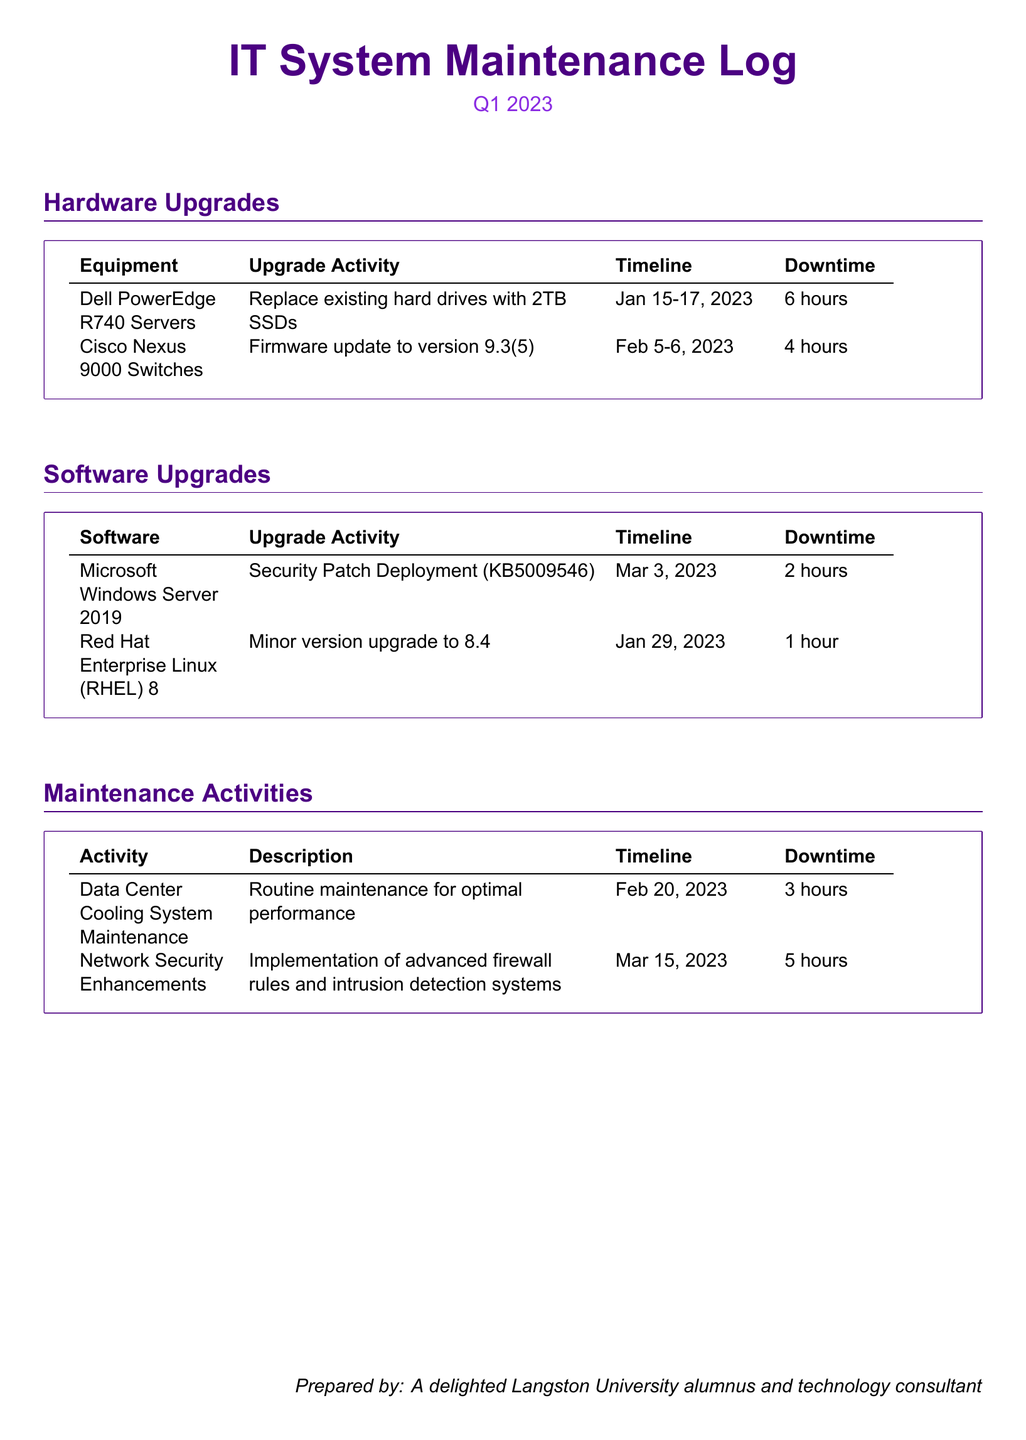what is the upgrade activity for the Dell PowerEdge R740 Servers? The upgrade activity is to replace existing hard drives with 2TB SSDs.
Answer: Replace existing hard drives with 2TB SSDs what is the timeline for the Cisco Nexus 9000 Switches upgrade? The timeline for the upgrade is from February 5-6, 2023.
Answer: February 5-6, 2023 how long is the downtime for the Microsoft Windows Server 2019 upgrade? The downtime for the upgrade is indicated in the document as 2 hours.
Answer: 2 hours what is the total downtime for all hardware upgrades? The total downtime is the sum of all downtime amounts listed under hardware upgrades, which is 6 hours + 4 hours = 10 hours.
Answer: 10 hours which software is upgraded to version 8.4? The software upgraded to version 8.4 is Red Hat Enterprise Linux (RHEL) 8.
Answer: Red Hat Enterprise Linux (RHEL) 8 what is the purpose of the Network Security Enhancements maintenance activity? The purpose is the implementation of advanced firewall rules and intrusion detection systems.
Answer: Implementation of advanced firewall rules and intrusion detection systems when is the routine maintenance for the Data Center Cooling System scheduled? The routine maintenance is scheduled for February 20, 2023.
Answer: February 20, 2023 who prepared the maintenance log document? The document was prepared by a delighted Langston University alumnus and technology consultant.
Answer: A delighted Langston University alumnus and technology consultant 